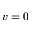<formula> <loc_0><loc_0><loc_500><loc_500>v = 0</formula> 